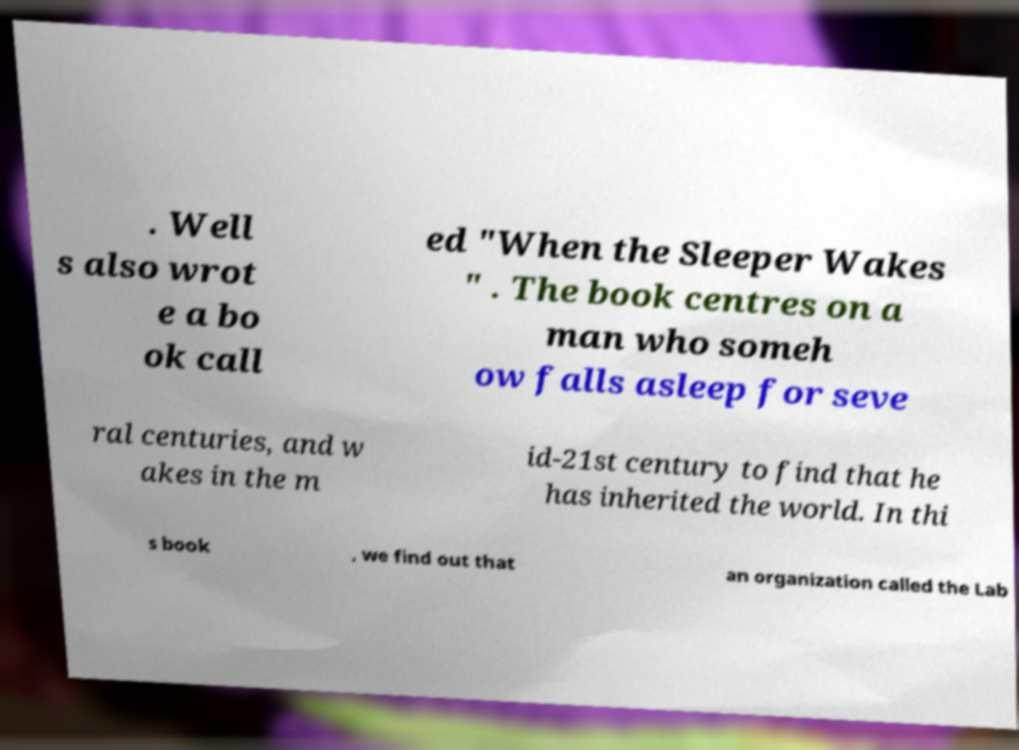I need the written content from this picture converted into text. Can you do that? . Well s also wrot e a bo ok call ed "When the Sleeper Wakes " . The book centres on a man who someh ow falls asleep for seve ral centuries, and w akes in the m id-21st century to find that he has inherited the world. In thi s book , we find out that an organization called the Lab 